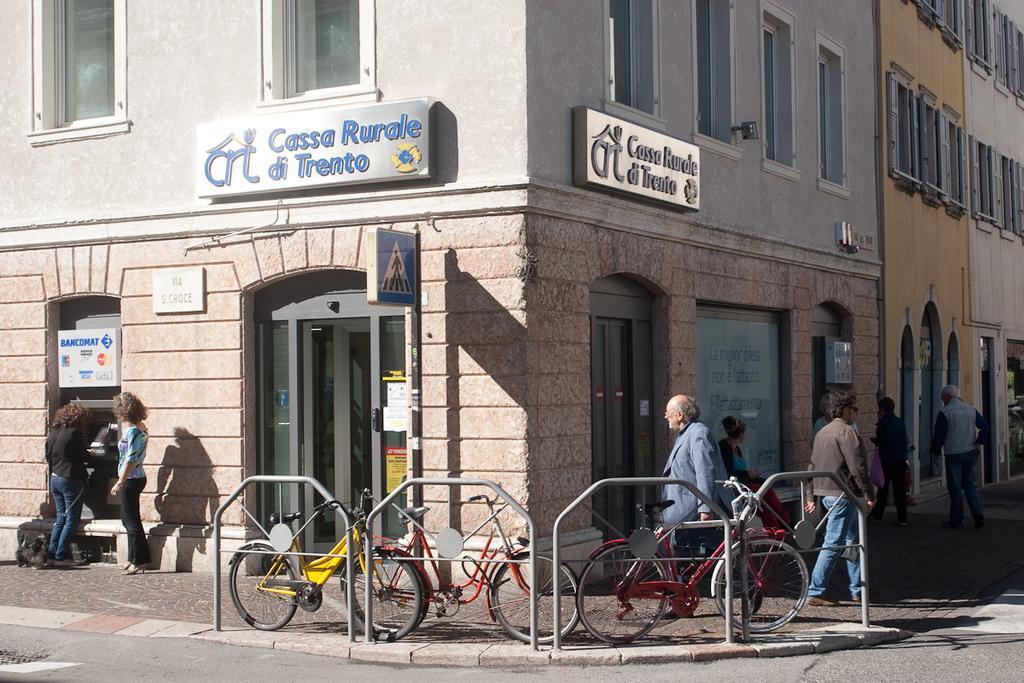Please provide a concise description of this image. In this image, we can see so many buildings with walls, windows. Here we can see few doors, hoardings, name boards, posters. At the bottom, there is a footpath. Few people are here. We can see few bicycles, rods and road. Right side of the image, we can see few people are walking. 